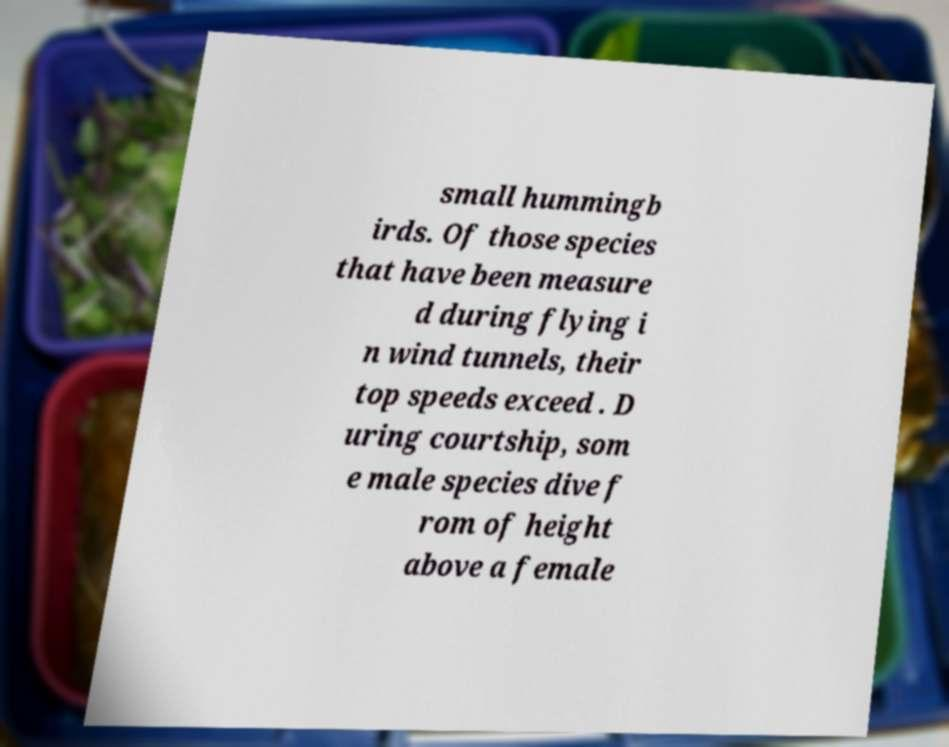Can you read and provide the text displayed in the image?This photo seems to have some interesting text. Can you extract and type it out for me? small hummingb irds. Of those species that have been measure d during flying i n wind tunnels, their top speeds exceed . D uring courtship, som e male species dive f rom of height above a female 